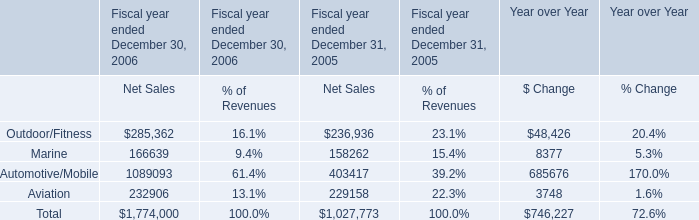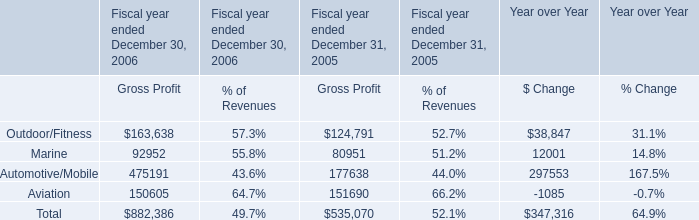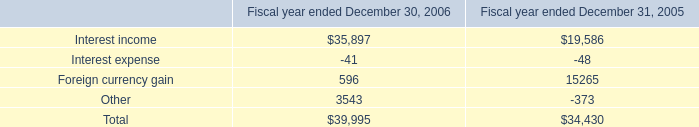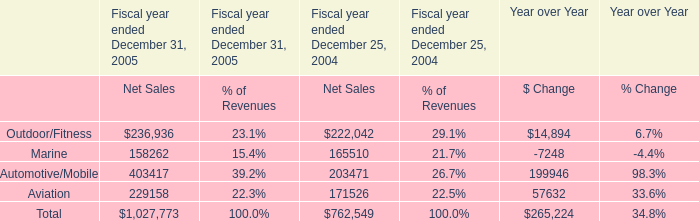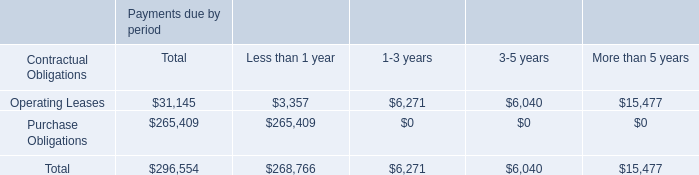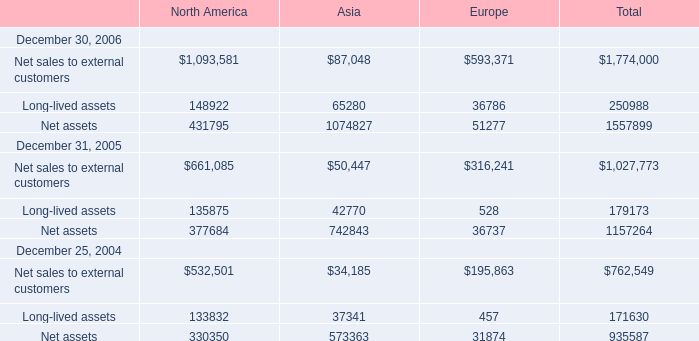How much is the Net assets for Europe at December 31, 2005 less than the 50 % of the Total Net assets at December 31, 2005? 
Computations: ((0.5 * 1157264) - 36737)
Answer: 541895.0. 